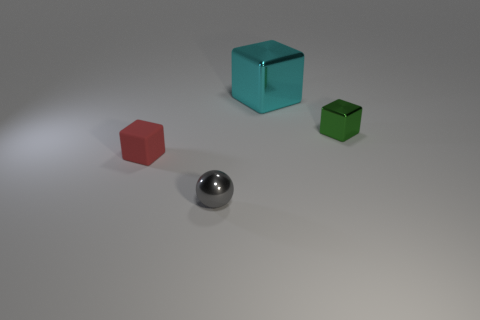Subtract 0 purple balls. How many objects are left? 4 Subtract all blocks. How many objects are left? 1 Subtract 1 blocks. How many blocks are left? 2 Subtract all brown blocks. Subtract all brown cylinders. How many blocks are left? 3 Subtract all brown balls. How many blue cubes are left? 0 Subtract all big brown shiny balls. Subtract all cyan metallic cubes. How many objects are left? 3 Add 2 gray metal balls. How many gray metal balls are left? 3 Add 2 gray matte cylinders. How many gray matte cylinders exist? 2 Add 2 tiny red cubes. How many objects exist? 6 Subtract all red blocks. How many blocks are left? 2 